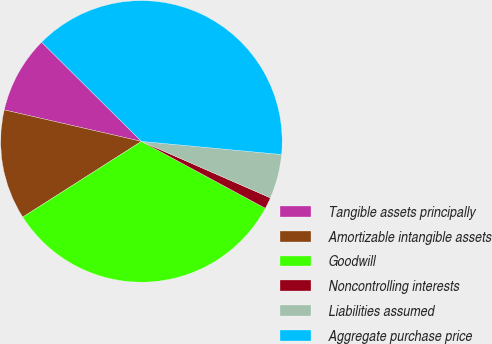<chart> <loc_0><loc_0><loc_500><loc_500><pie_chart><fcel>Tangible assets principally<fcel>Amortizable intangible assets<fcel>Goodwill<fcel>Noncontrolling interests<fcel>Liabilities assumed<fcel>Aggregate purchase price<nl><fcel>8.86%<fcel>12.63%<fcel>33.09%<fcel>1.31%<fcel>5.08%<fcel>39.04%<nl></chart> 